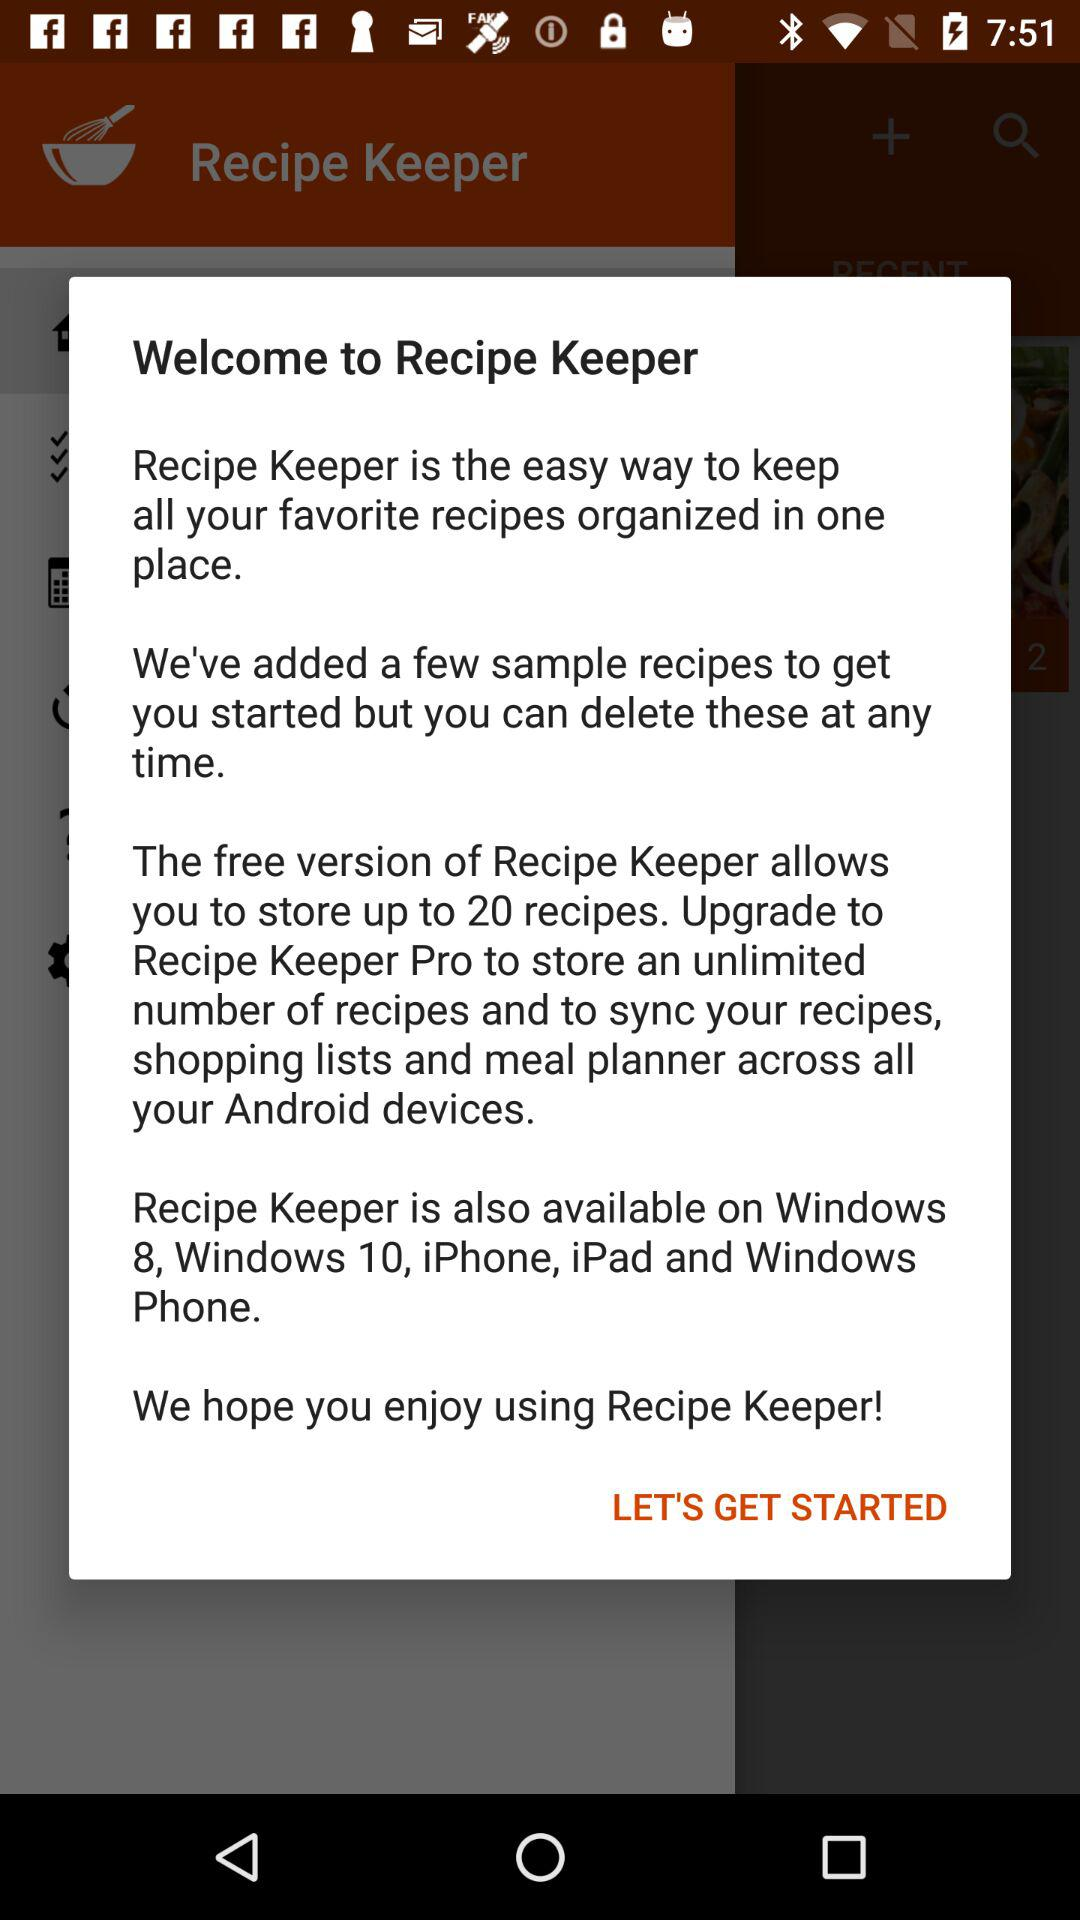How many recipes can be stored in the free version of Recipe Keeper?
Answer the question using a single word or phrase. 20 